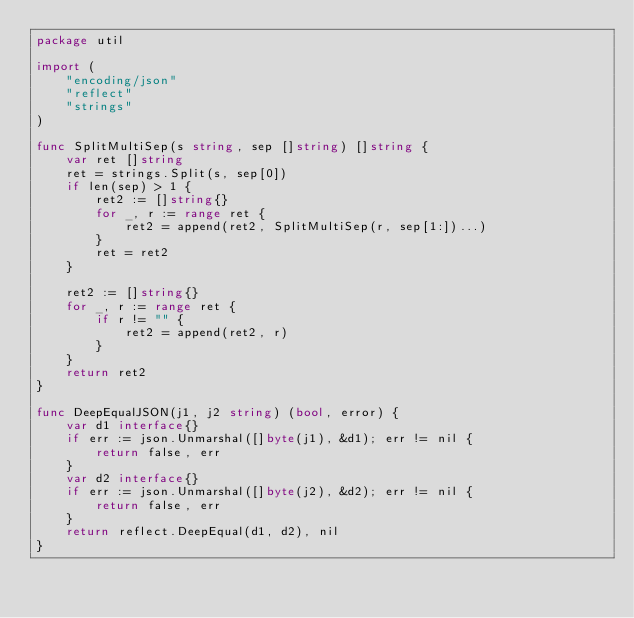<code> <loc_0><loc_0><loc_500><loc_500><_Go_>package util

import (
	"encoding/json"
	"reflect"
	"strings"
)

func SplitMultiSep(s string, sep []string) []string {
	var ret []string
	ret = strings.Split(s, sep[0])
	if len(sep) > 1 {
		ret2 := []string{}
		for _, r := range ret {
			ret2 = append(ret2, SplitMultiSep(r, sep[1:])...)
		}
		ret = ret2
	}

	ret2 := []string{}
	for _, r := range ret {
		if r != "" {
			ret2 = append(ret2, r)
		}
	}
	return ret2
}

func DeepEqualJSON(j1, j2 string) (bool, error) {
	var d1 interface{}
	if err := json.Unmarshal([]byte(j1), &d1); err != nil {
		return false, err
	}
	var d2 interface{}
	if err := json.Unmarshal([]byte(j2), &d2); err != nil {
		return false, err
	}
	return reflect.DeepEqual(d1, d2), nil
}
</code> 